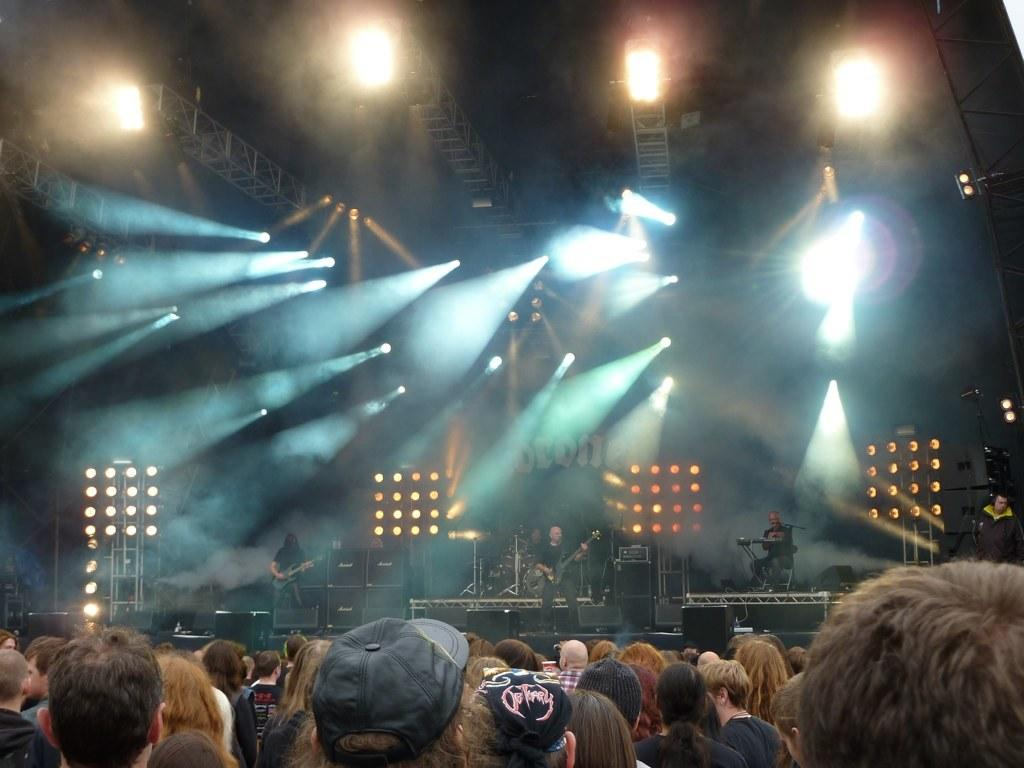What is happening in the image involving a group of people? There is a group of people in the image, but their specific activity is not mentioned in the facts. Are there any musicians in the image? Yes, there are people playing musical instruments in the background. What can be seen illuminated in the image? There are lights visible in the image. What type of structures are present in the image? There are poles in the image. What type of flower is being watered by the hose in the image? There is no flower or hose present in the image. 